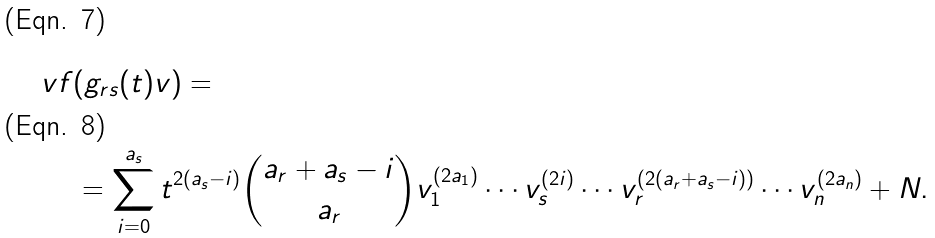<formula> <loc_0><loc_0><loc_500><loc_500>\ v f & ( g _ { r s } ( t ) v ) = \\ & = \sum ^ { a _ { s } } _ { i = 0 } t ^ { 2 ( a _ { s } - i ) } \binom { a _ { r } + a _ { s } - i } { a _ { r } } v ^ { ( 2 a _ { 1 } ) } _ { 1 } \cdots v ^ { ( 2 i ) } _ { s } \cdots v ^ { ( 2 ( a _ { r } + a _ { s } - i ) ) } _ { r } \cdots v ^ { ( 2 a _ { n } ) } _ { n } + N .</formula> 